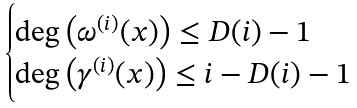<formula> <loc_0><loc_0><loc_500><loc_500>\begin{cases} \deg \left ( \omega ^ { ( i ) } ( x ) \right ) \leq D ( i ) - 1 \\ \deg \left ( \gamma ^ { ( i ) } ( x ) \right ) \leq i - D ( i ) - 1 \end{cases}</formula> 